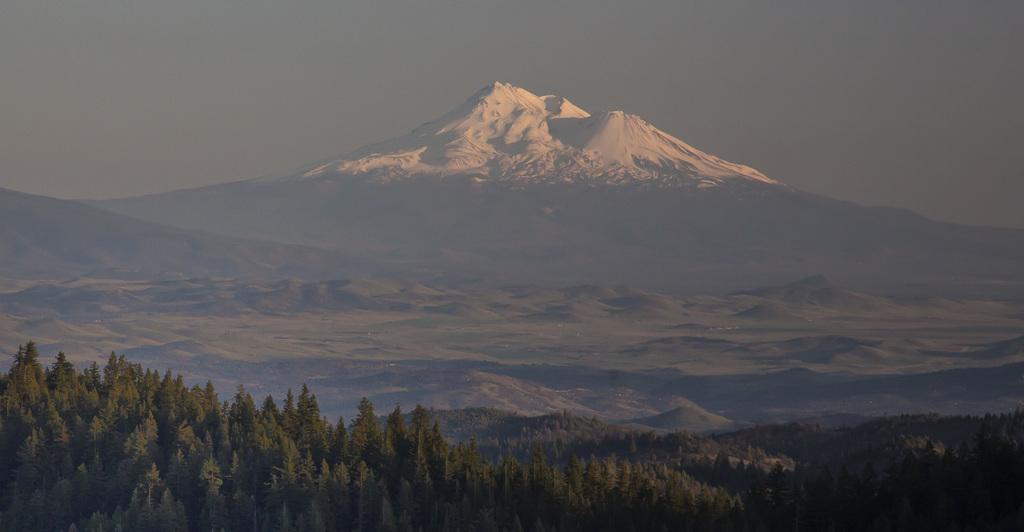Please provide a concise description of this image. In the foreground of the image we can see a group of trees. In the background, we can see mountains and the sky. 